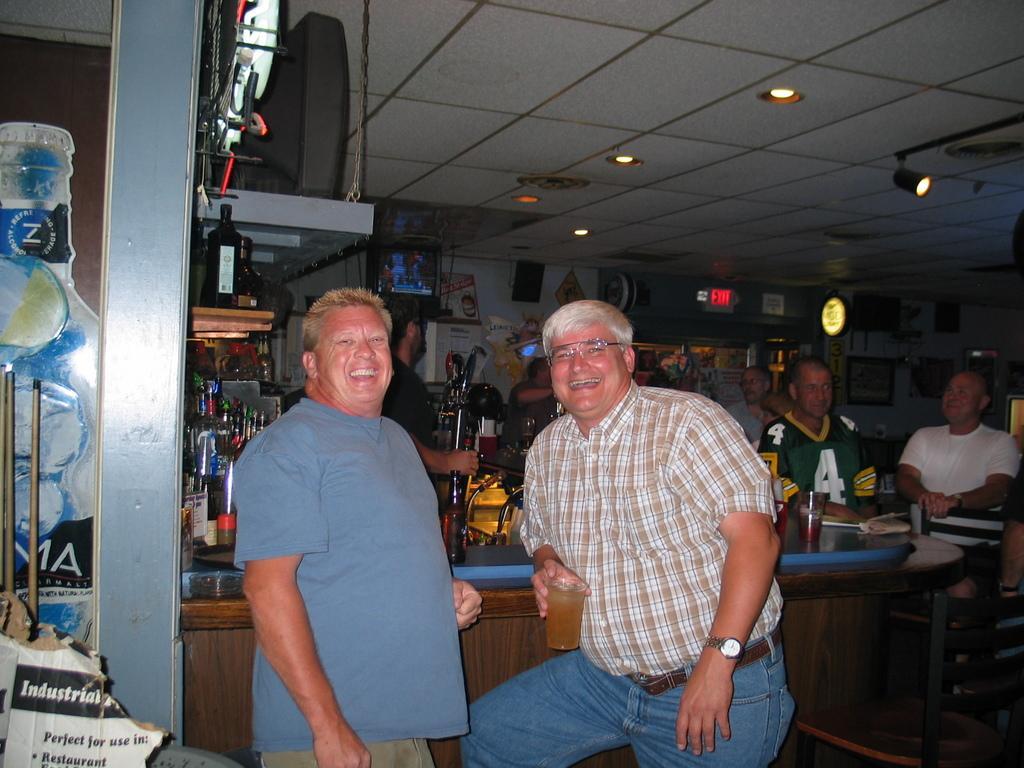Describe this image in one or two sentences. In this picture few persons are there. These two person sitting on the chair. These persons standing. We can see table. On the table we can see bottle,glass. This person holding a glass. On the top we can see lights. This is television. On the background We can see wall,television,Board. 